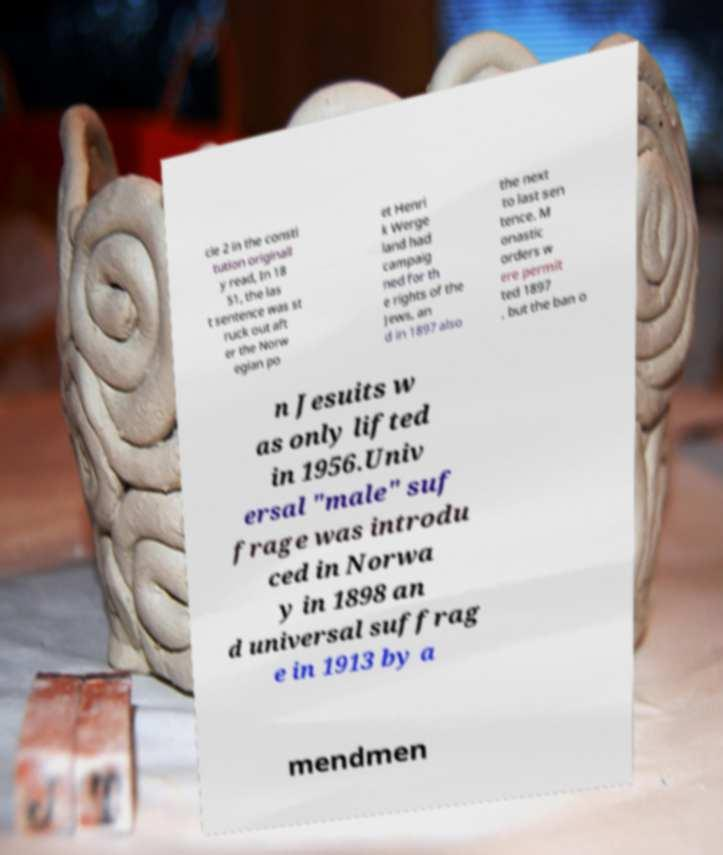What messages or text are displayed in this image? I need them in a readable, typed format. cle 2 in the consti tution originall y read, In 18 51, the las t sentence was st ruck out aft er the Norw egian po et Henri k Werge land had campaig ned for th e rights of the Jews, an d in 1897 also the next to last sen tence. M onastic orders w ere permit ted 1897 , but the ban o n Jesuits w as only lifted in 1956.Univ ersal "male" suf frage was introdu ced in Norwa y in 1898 an d universal suffrag e in 1913 by a mendmen 